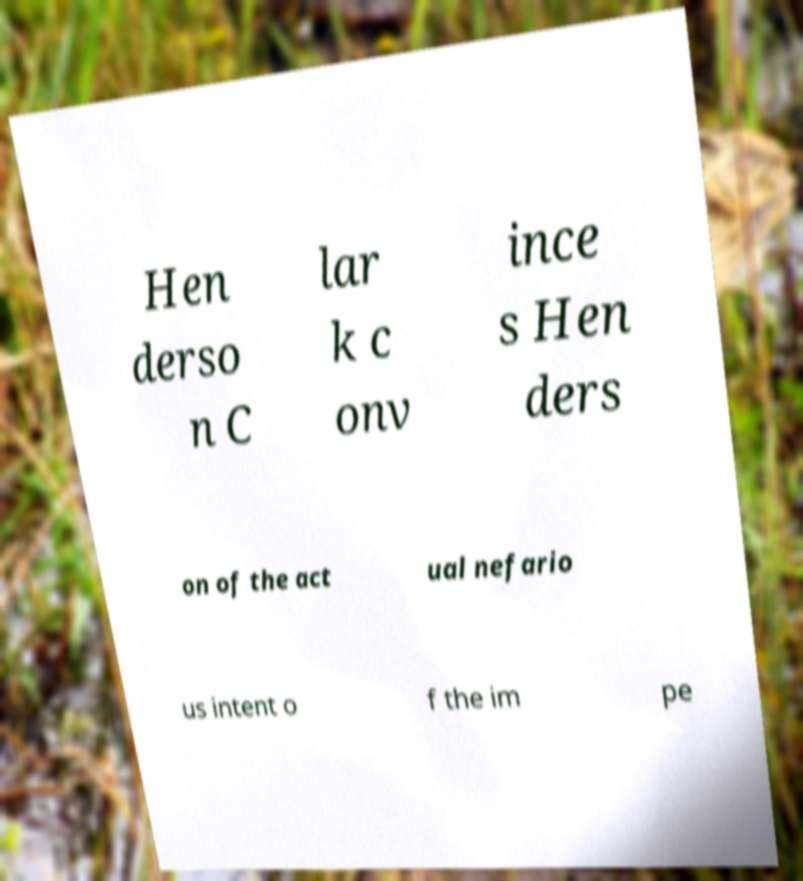There's text embedded in this image that I need extracted. Can you transcribe it verbatim? Hen derso n C lar k c onv ince s Hen ders on of the act ual nefario us intent o f the im pe 